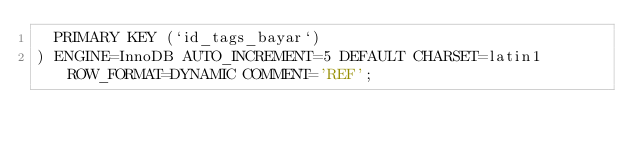<code> <loc_0><loc_0><loc_500><loc_500><_SQL_>  PRIMARY KEY (`id_tags_bayar`)
) ENGINE=InnoDB AUTO_INCREMENT=5 DEFAULT CHARSET=latin1 ROW_FORMAT=DYNAMIC COMMENT='REF';
</code> 